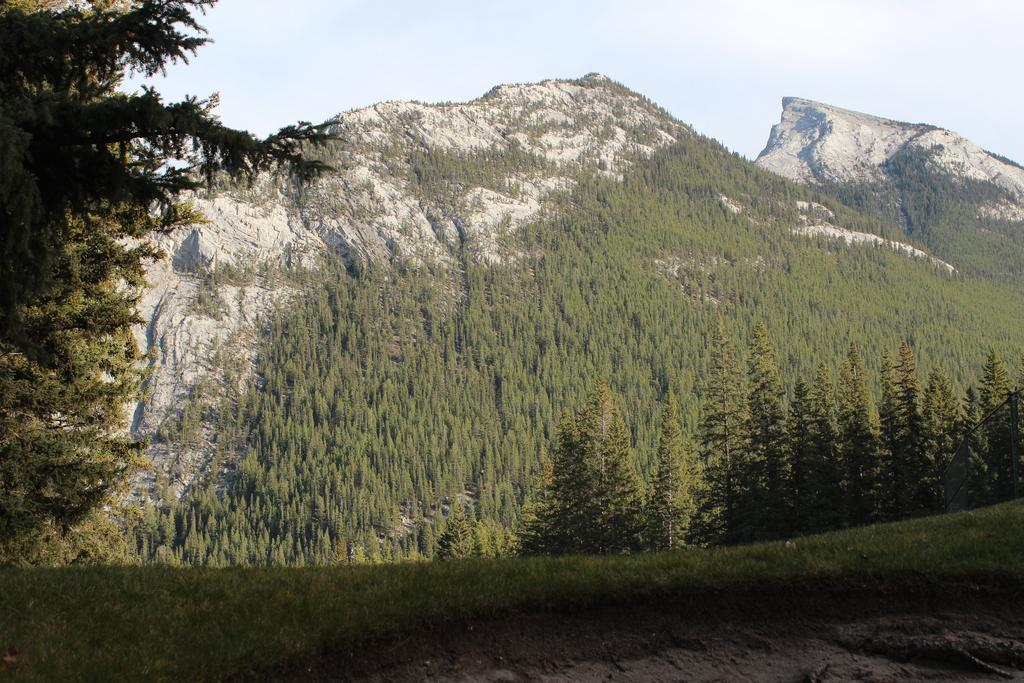What type of terrain is visible in the image? There are hills and a grassy land visible in the image. What type of vegetation is present in the image? There are many trees in the image. What part of the natural environment is visible in the image? The sky is visible in the image. Can you tell me how many words are written on the grass in the image? There are no words written on the grass in the image; it is a natural landscape with hills, trees, and grassy land. 